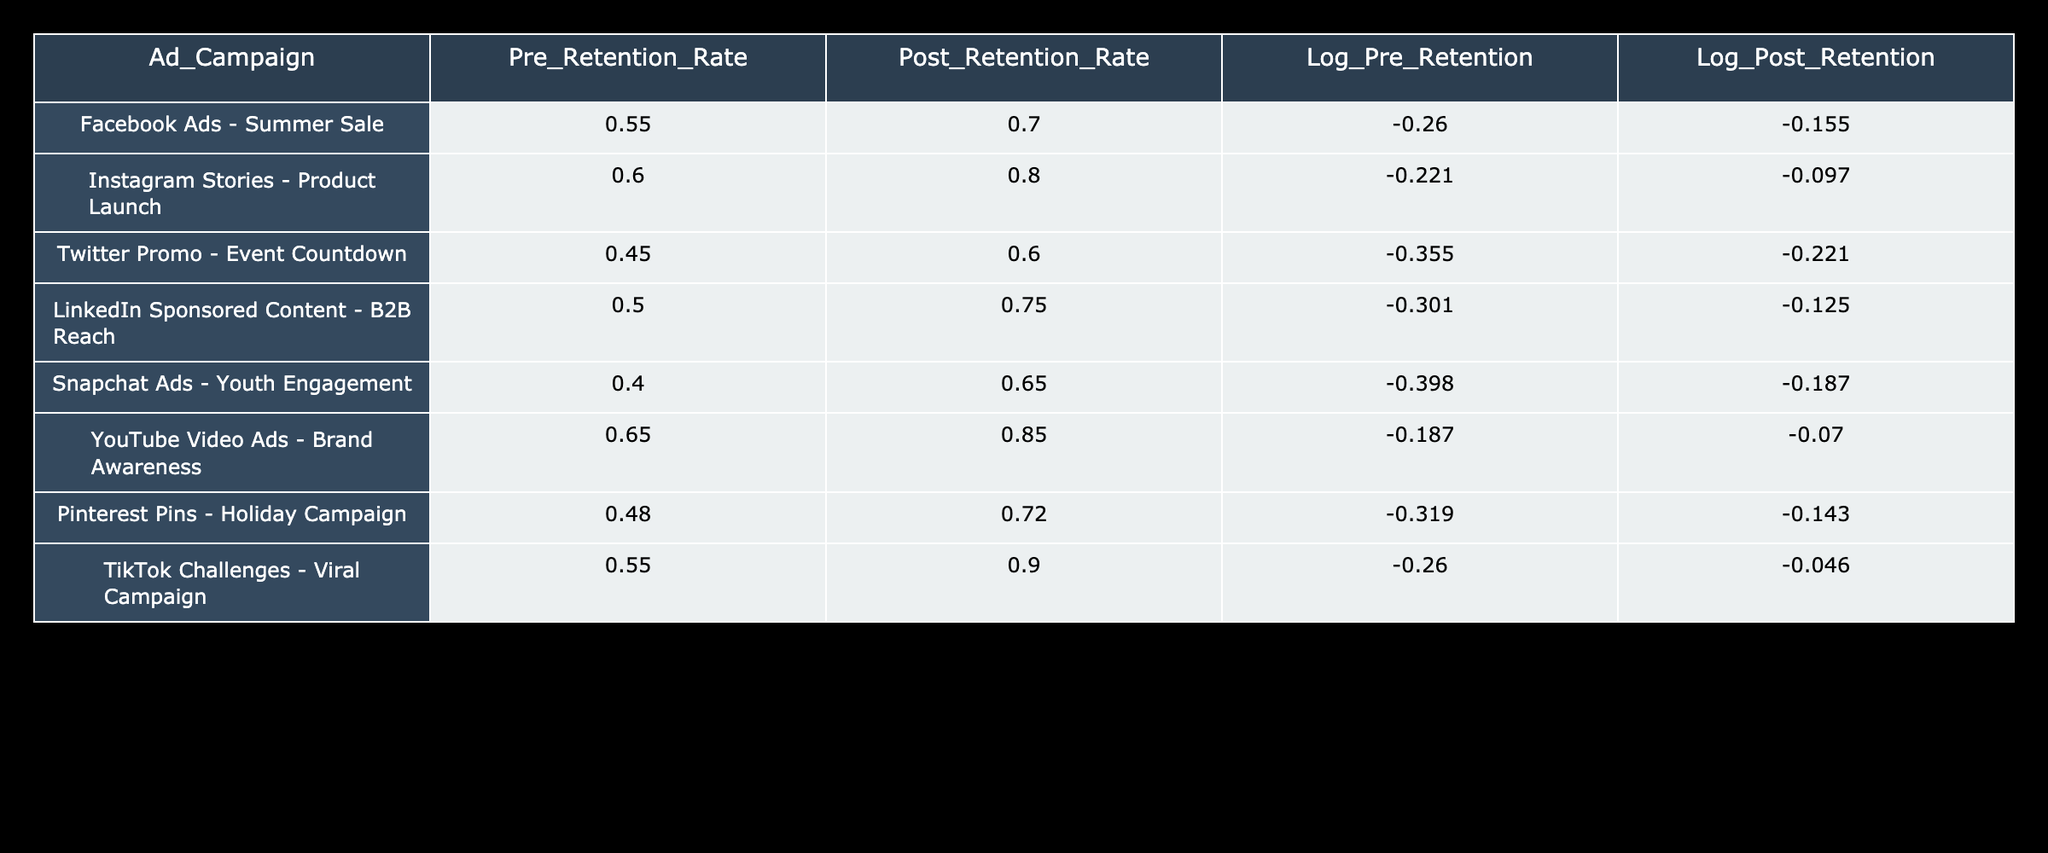What is the highest post-retention rate achieved by any ad campaign? By examining the "Post_Retention_Rate" column, the highest value is 0.90, which corresponds to "TikTok Challenges - Viral Campaign."
Answer: 0.90 Which ad campaign had the lowest pre-retention rate? Looking at the "Pre_Retention_Rate" column, the lowest value is 0.40, associated with the "Snapchat Ads - Youth Engagement."
Answer: 0.40 What was the increase in retention rate for the "YouTube Video Ads - Brand Awareness" campaign? To find the increase, subtract the "Pre_Retention_Rate" (0.65) from the "Post_Retention_Rate" (0.85): 0.85 - 0.65 = 0.20.
Answer: 0.20 Is it true that all campaigns had an increase in retention rate? By checking each row, all post-retention rates are higher than the pre-retention rates, confirming that every campaign indeed saw an increase.
Answer: Yes What is the average post-retention rate for all campaigns? Summing the "Post_Retention_Rate" values (0.70 + 0.80 + 0.60 + 0.75 + 0.65 + 0.85 + 0.72 + 0.90) gives a total of 5.27. Dividing by the number of campaigns (8) results in an average of 5.27 / 8 = 0.65875, which can be rounded to 0.66.
Answer: 0.66 What is the difference in the log values between the highest and lowest post-retention rates? First, identify the highest log value for post-retention (for TikTok at -0.046) and the lowest log value (for Twitter at -0.221). Calculate the difference: -0.046 - (-0.221) = 0.175.
Answer: 0.175 Which ad campaign saw the largest percentage increase in retention rate? The percentage increase can be calculated using the formula: ((Post_Retention - Pre_Retention) / Pre_Retention) * 100%. For "TikTok Challenges - Viral Campaign," the values are 0.90 and 0.55: ((0.90 - 0.55) / 0.55) * 100% = 63.64%. This is the largest percentage increase compared to the others.
Answer: TikTok Challenges - Viral Campaign How many campaigns resulted in a post-retention rate higher than 0.75? By reviewing the "Post_Retention_Rate" column, the values greater than 0.75 are 0.80, 0.75, 0.85, and 0.90, indicating that there are four campaigns with post-retention rates above 0.75.
Answer: 4 